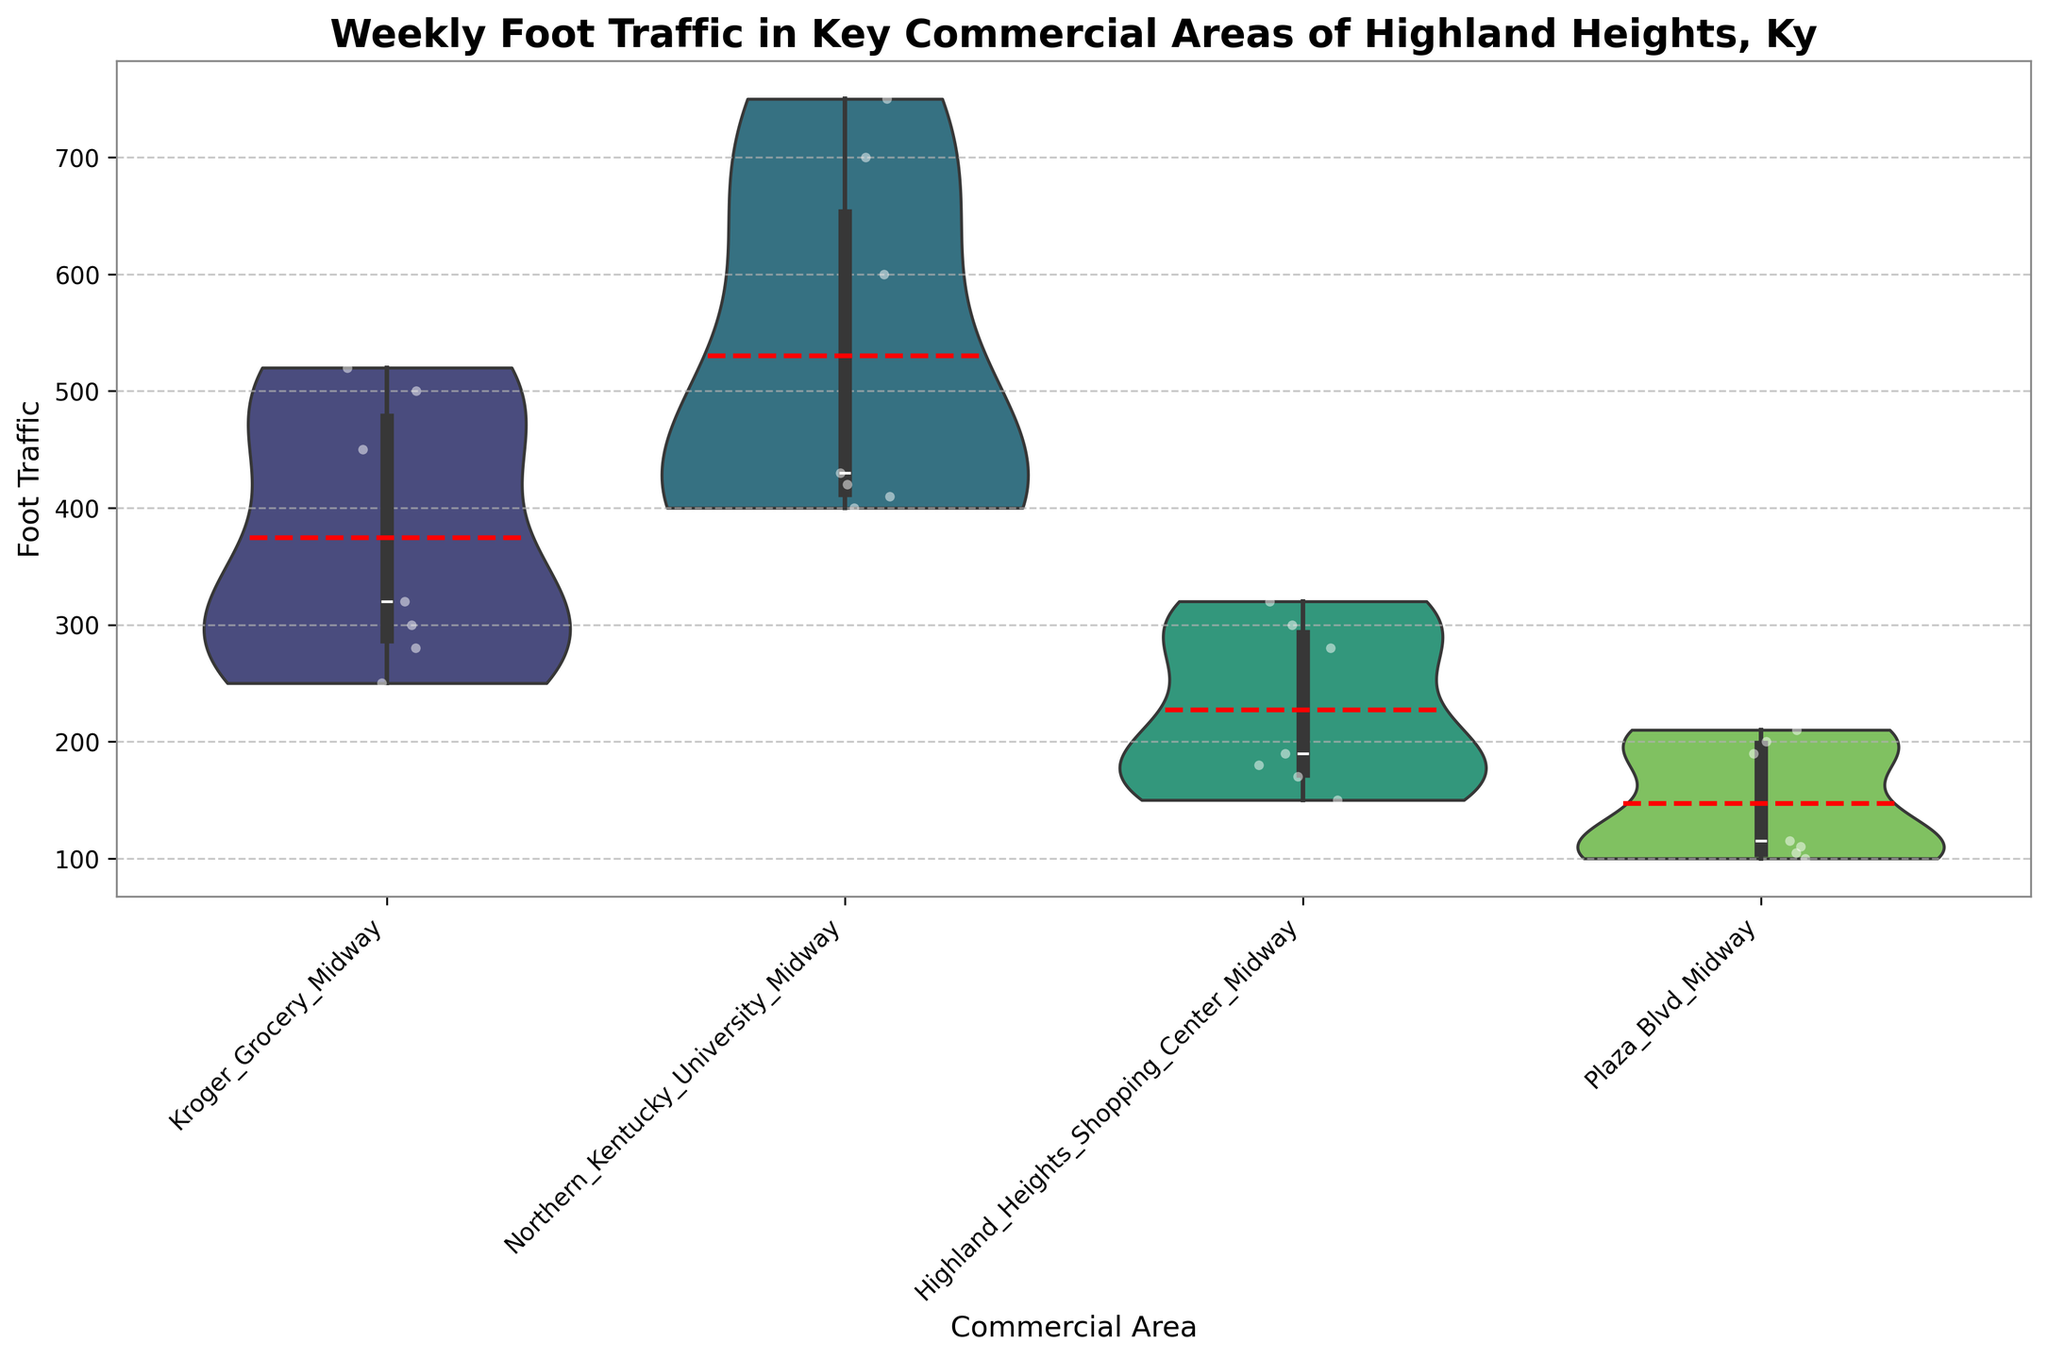What's the title of the figure? The title is prominently displayed at the top of the figure. It reads "Weekly Foot Traffic in Key Commercial Areas of Highland Heights, Ky".
Answer: Weekly Foot Traffic in Key Commercial Areas of Highland Heights, Ky What are the commercial areas shown in the figure? Each commercial area is represented on the x-axis. They are Kroger Grocery Midway, Northern Kentucky University Midway, Highland Heights Shopping Center Midway, and Plaza Blvd Midway.
Answer: Kroger Grocery Midway, Northern Kentucky University Midway, Highland Heights Shopping Center Midway, Plaza Blvd Midway Which commercial area sees the highest average foot traffic? The average foot traffic for each area can be inferred from the red dashed lines indicating the mean values. Northern Kentucky University Midway has the highest mean line, indicating the highest average foot traffic.
Answer: Northern Kentucky University Midway On which day does Kroger Grocery Midway experience the highest foot traffic? Each day's foot traffic is represented by individual points, and the highest point for Kroger Grocery Midway is on Saturday.
Answer: Saturday How does the foot traffic on Friday at Northern Kentucky University Midway compare to the same day at other locations? The foot traffic on Friday for Northern Kentucky University Midway is visibly higher than for the other locations. This is evident from the height of the corresponding point on the violin plot.
Answer: Higher Are there any outliers in the foot traffic data? If so, where? Outliers in box plots are typically depicted with individual points beyond the whiskers of the box. There are no distinct outliers shown in the figure for any commercial area.
Answer: No What is the median foot traffic for Plaza Blvd Midway? The median is represented by a line within the box of the box plot inside the violin plot. The median for Plaza Blvd Midway is approximately 110.
Answer: 110 Which day of the week has the lowest foot traffic for Highland Heights Shopping Center Midway? The lowest individual points within the violin plot for Highland Heights Shopping Center Midway are on Monday.
Answer: Monday Does the violin plot show more variation in foot traffic for Kroger Grocery Midway or Plaza Blvd Midway? The width of the violin plot indicates the distribution spread. Kroger Grocery Midway’s plot is wider, indicating more variation in foot traffic compared to Plaza Blvd Midway.
Answer: Kroger Grocery Midway How does Saturday's foot traffic at Northern Kentucky University Midway compare to other days within the same location? Saturday's foot traffic is one of the highest within Northern Kentucky University Midway, as indicated by the top range of the violin plot being much higher for that day.
Answer: Higher 